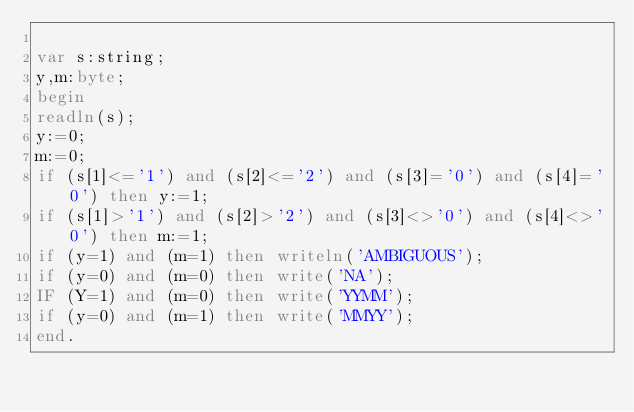<code> <loc_0><loc_0><loc_500><loc_500><_Pascal_>
var s:string;
y,m:byte;
begin
readln(s);
y:=0;
m:=0;
if (s[1]<='1') and (s[2]<='2') and (s[3]='0') and (s[4]='0') then y:=1;
if (s[1]>'1') and (s[2]>'2') and (s[3]<>'0') and (s[4]<>'0') then m:=1;
if (y=1) and (m=1) then writeln('AMBIGUOUS');
if (y=0) and (m=0) then write('NA');
IF (Y=1) and (m=0) then write('YYMM');
if (y=0) and (m=1) then write('MMYY');
end.</code> 